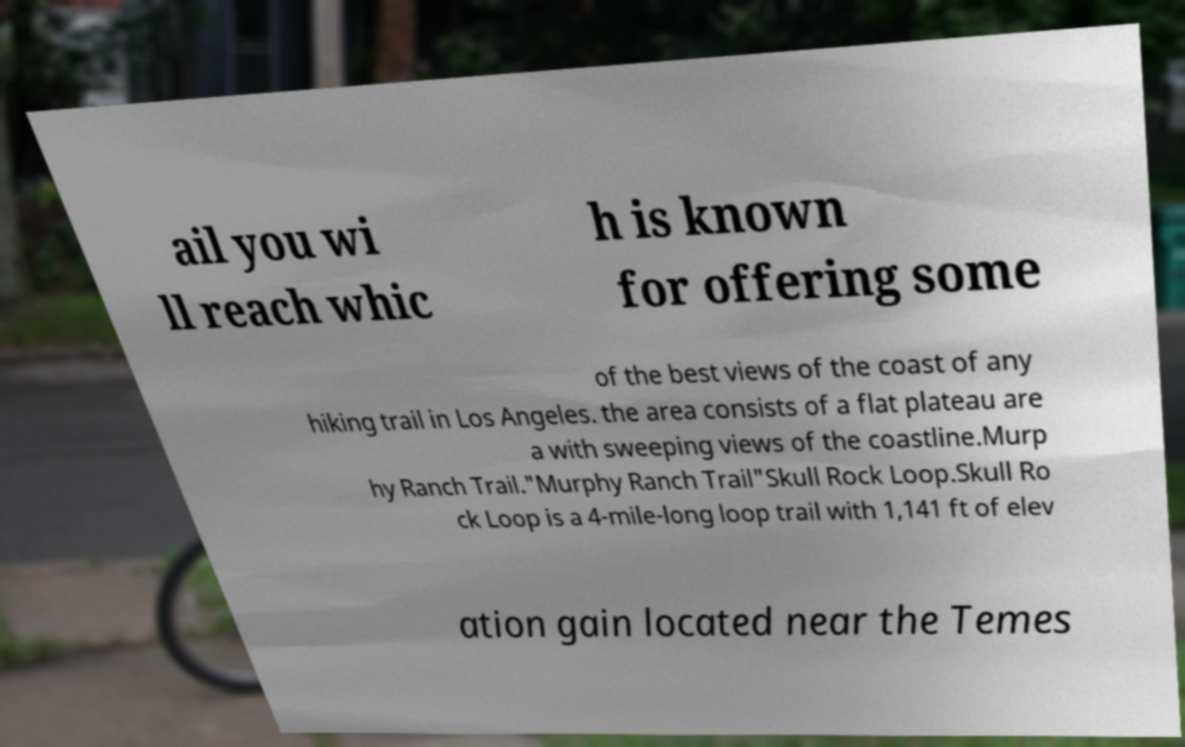Please identify and transcribe the text found in this image. ail you wi ll reach whic h is known for offering some of the best views of the coast of any hiking trail in Los Angeles. the area consists of a flat plateau are a with sweeping views of the coastline.Murp hy Ranch Trail."Murphy Ranch Trail"Skull Rock Loop.Skull Ro ck Loop is a 4-mile-long loop trail with 1,141 ft of elev ation gain located near the Temes 